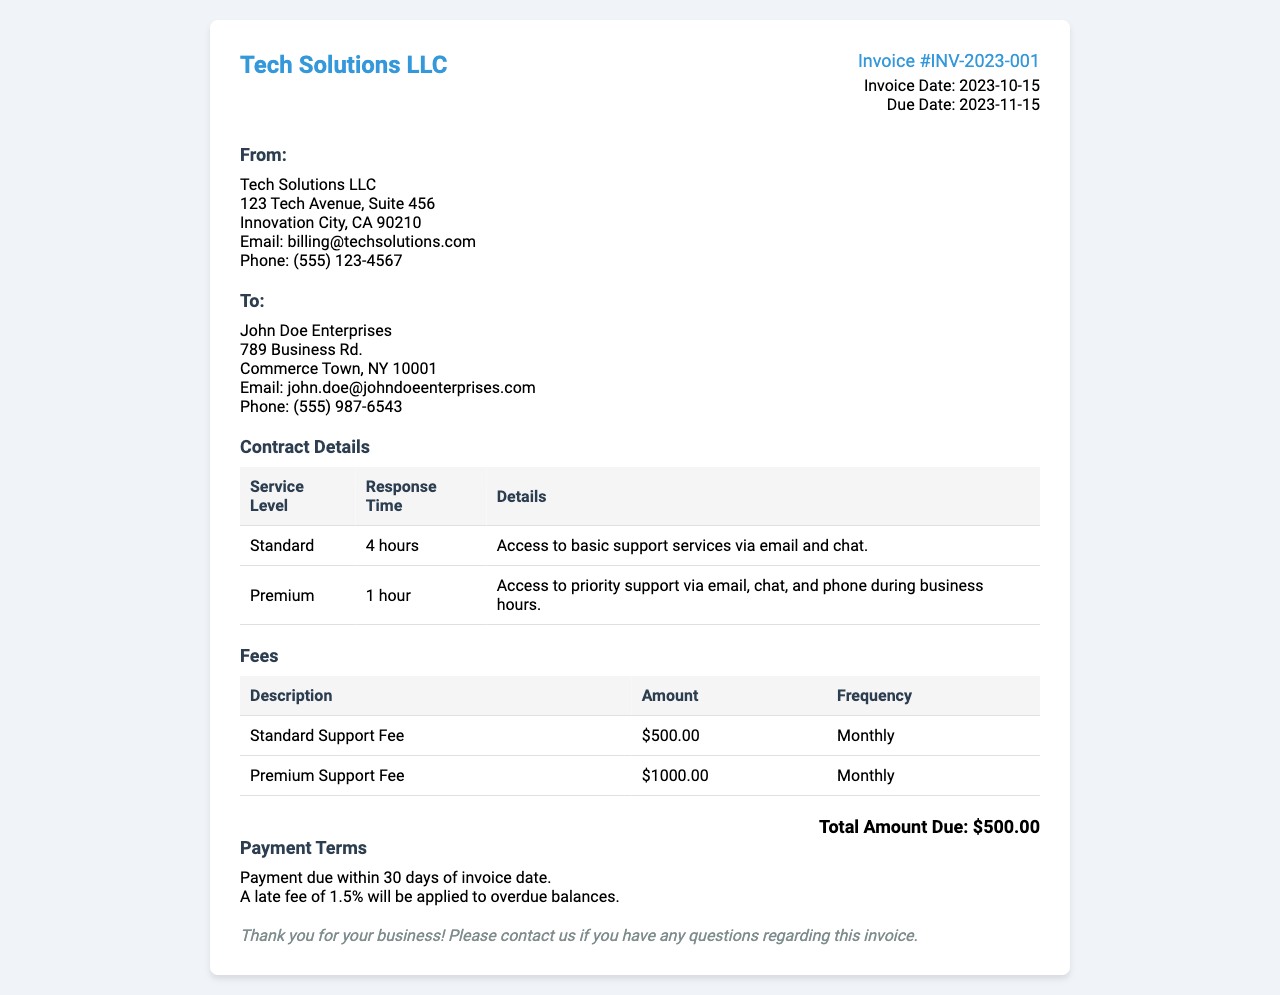What is the invoice number? The invoice number is located in the header section of the document.
Answer: INV-2023-001 What is the total amount due? The total amount due is stated at the bottom of the invoice.
Answer: $500.00 What is the invoice date? The invoice date is provided alongside the invoice number in the document.
Answer: 2023-10-15 What is the response time for Standard support? The response time for Standard support is indicated in the contract details table.
Answer: 4 hours Who is the recipient of the invoice? The recipient's information is listed under the "To:" section of the document.
Answer: John Doe Enterprises What services are included in Premium support? Premium support details are given in the contract details section.
Answer: Access to priority support via email, chat, and phone during business hours What is the frequency of the Standard Support Fee? The frequency is specified in the fees table.
Answer: Monthly What will happen if payment is overdue? The consequences of overdue payment are outlined in the payment terms section.
Answer: A late fee of 1.5% will be applied What is the address of Tech Solutions LLC? Tech Solutions LLC's address can be found in the "From:" section of the invoice.
Answer: 123 Tech Avenue, Suite 456 